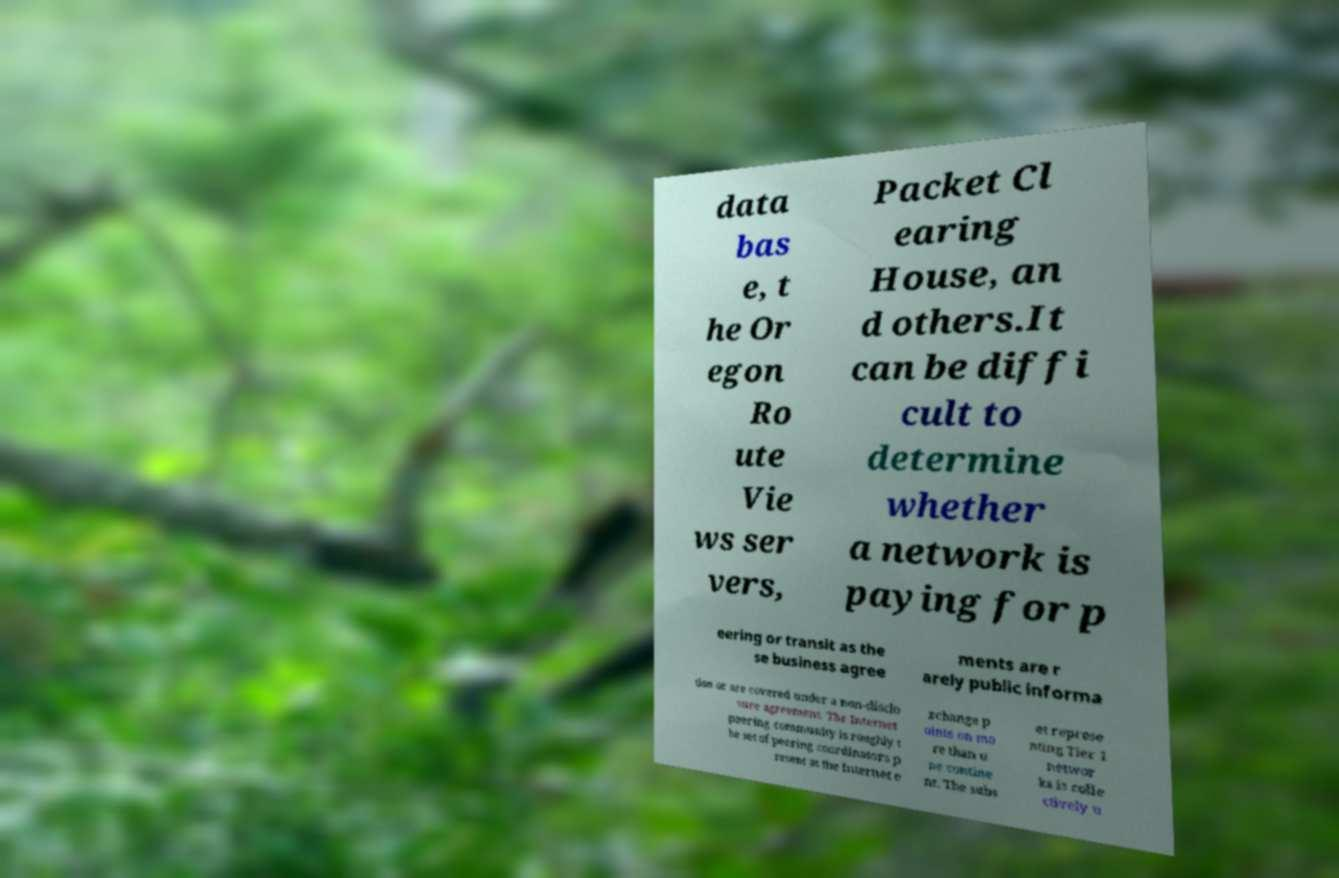I need the written content from this picture converted into text. Can you do that? data bas e, t he Or egon Ro ute Vie ws ser vers, Packet Cl earing House, an d others.It can be diffi cult to determine whether a network is paying for p eering or transit as the se business agree ments are r arely public informa tion or are covered under a non-disclo sure agreement. The Internet peering community is roughly t he set of peering coordinators p resent at the Internet e xchange p oints on mo re than o ne contine nt. The subs et represe nting Tier 1 networ ks is colle ctively u 